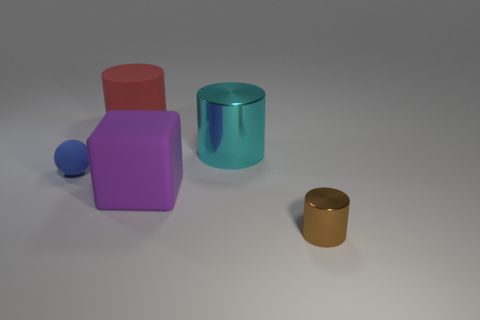Do the textures of the objects differ or are they the same? The textures of the objects look similar with a smooth and slightly reflective surface, suggesting they might be made of the same material or have similar finishes. 